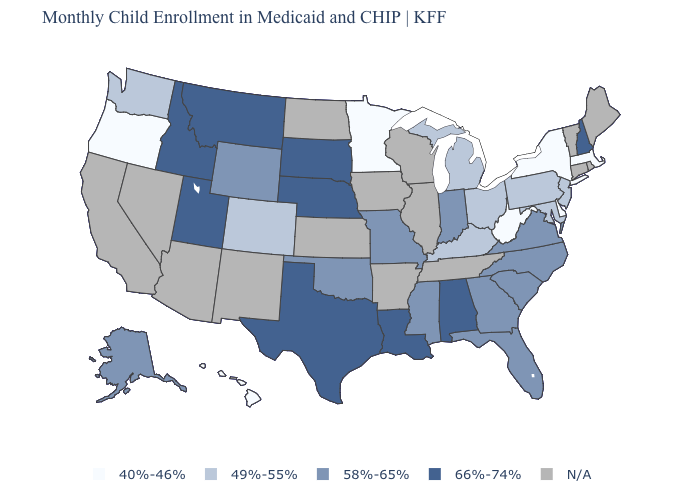What is the value of Tennessee?
Be succinct. N/A. Name the states that have a value in the range 40%-46%?
Short answer required. Delaware, Hawaii, Massachusetts, Minnesota, New York, Oregon, West Virginia. Name the states that have a value in the range N/A?
Be succinct. Arizona, Arkansas, California, Connecticut, Illinois, Iowa, Kansas, Maine, Nevada, New Mexico, North Dakota, Rhode Island, Tennessee, Vermont, Wisconsin. What is the value of Alaska?
Write a very short answer. 58%-65%. Name the states that have a value in the range 58%-65%?
Answer briefly. Alaska, Florida, Georgia, Indiana, Mississippi, Missouri, North Carolina, Oklahoma, South Carolina, Virginia, Wyoming. Name the states that have a value in the range 66%-74%?
Concise answer only. Alabama, Idaho, Louisiana, Montana, Nebraska, New Hampshire, South Dakota, Texas, Utah. What is the highest value in states that border Georgia?
Write a very short answer. 66%-74%. What is the value of Louisiana?
Answer briefly. 66%-74%. What is the value of New York?
Short answer required. 40%-46%. What is the lowest value in the USA?
Write a very short answer. 40%-46%. What is the value of Alabama?
Short answer required. 66%-74%. What is the value of Wyoming?
Short answer required. 58%-65%. 